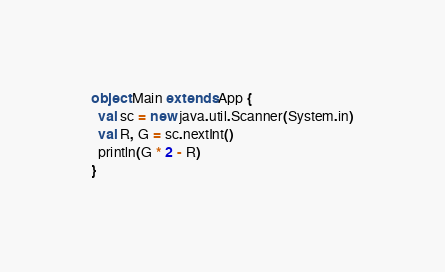Convert code to text. <code><loc_0><loc_0><loc_500><loc_500><_Scala_>object Main extends App {
  val sc = new java.util.Scanner(System.in)
  val R, G = sc.nextInt()
  println(G * 2 - R)
}
</code> 